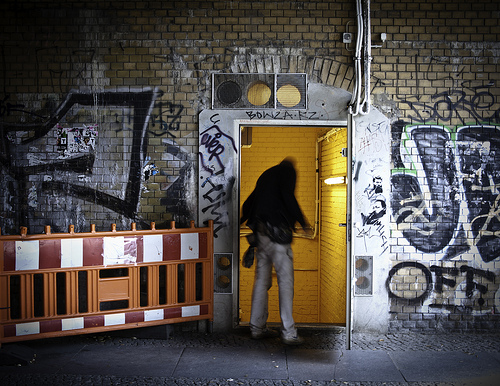Please provide the bounding box coordinate of the region this sentence describes: a hole in the wall. Certainly, the coordinates [0.71, 0.63, 0.74, 0.65] mark the location of the hole. It's situated on the lower part of a graffiti-filled wall, adding a unique element to the urban texture. 